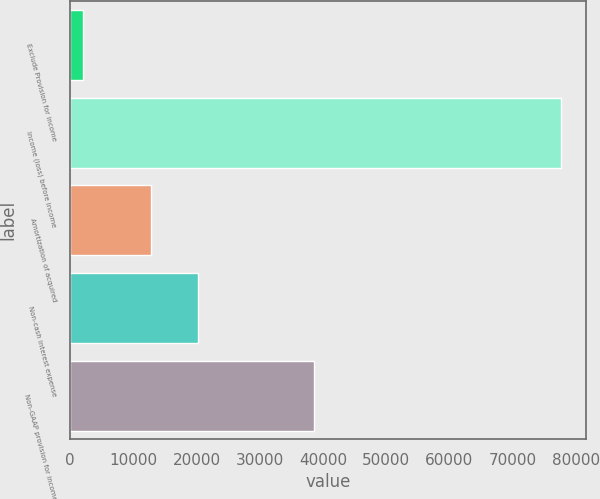<chart> <loc_0><loc_0><loc_500><loc_500><bar_chart><fcel>Exclude Provision for income<fcel>Income (loss) before income<fcel>Amortization of acquired<fcel>Non-cash interest expense<fcel>Non-GAAP provision for income<nl><fcel>2028<fcel>77703<fcel>12730<fcel>20297.5<fcel>38613<nl></chart> 